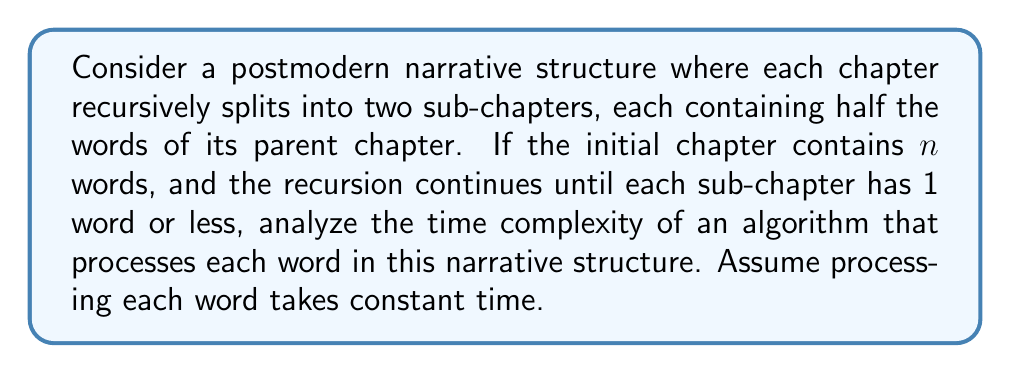Provide a solution to this math problem. To analyze the time complexity of this recursive algorithm, we need to consider the structure of the narrative and how it relates to the recursive process:

1. Initial state: We start with one chapter containing $n$ words.

2. Recursive process: Each chapter splits into two sub-chapters, each with half the words.

3. Base case: The recursion stops when a chapter has 1 word or less.

4. Processing: Each word is processed once, taking constant time.

Let's break down the analysis:

1. Number of levels in the recursion:
   The number of times we can halve $n$ until we reach 1 is $\log_2(n)$. So, the depth of the recursion is $\lceil \log_2(n) \rceil$.

2. Number of chapters at each level:
   - Level 0 (initial): 1 chapter
   - Level 1: 2 chapters
   - Level 2: 4 chapters
   - ...
   - Level $i$: $2^i$ chapters

3. Total number of words processed:
   At each level, we process all $n$ words once. The number of levels is $\lceil \log_2(n) \rceil$.

4. Time complexity:
   The total time is proportional to the number of words processed across all levels:
   
   $$T(n) = n \cdot \lceil \log_2(n) \rceil$$

This can be simplified to $O(n \log n)$ in Big O notation, as the ceiling function doesn't affect the asymptotic growth rate.

The recursion tree resembles a complete binary tree, which is characteristic of divide-and-conquer algorithms. This structure aligns well with postmodern narrative techniques that often employ fragmentation and non-linear storytelling.
Answer: The time complexity of the algorithm is $O(n \log n)$, where $n$ is the number of words in the initial chapter. 